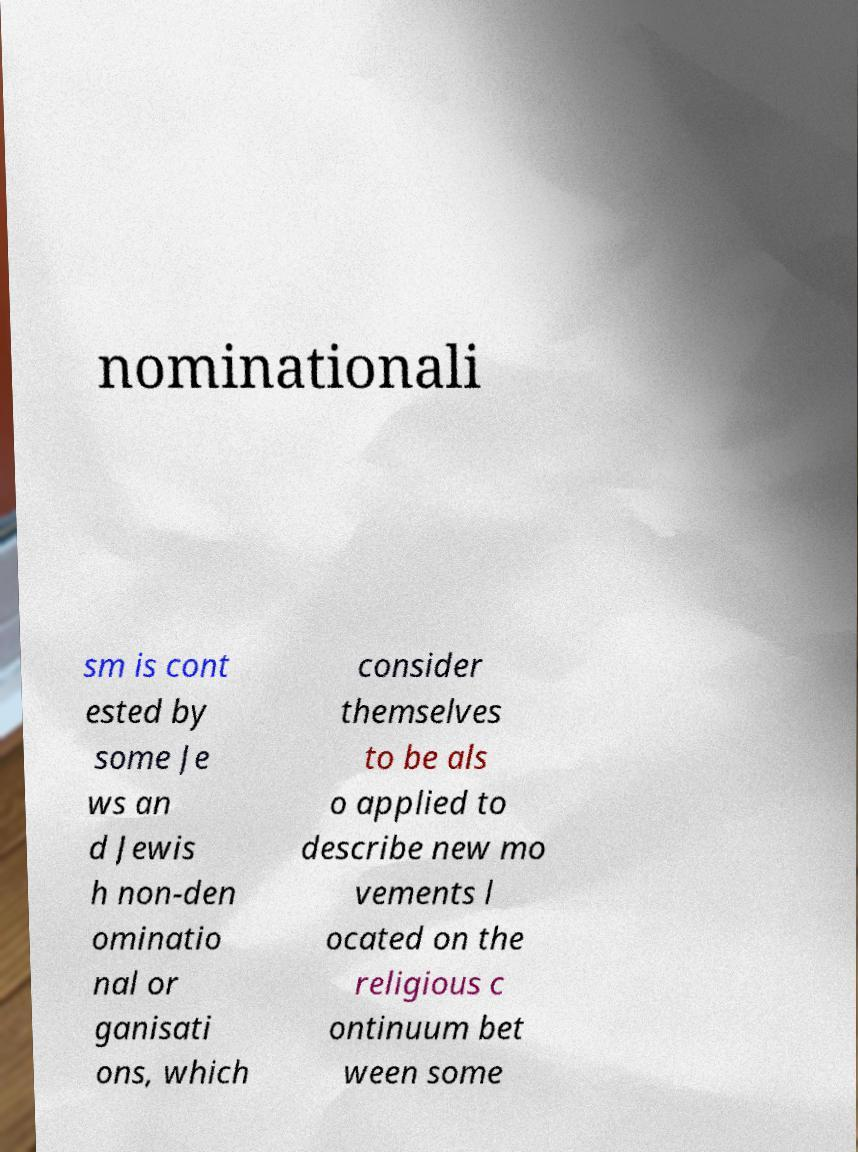Can you accurately transcribe the text from the provided image for me? nominationali sm is cont ested by some Je ws an d Jewis h non-den ominatio nal or ganisati ons, which consider themselves to be als o applied to describe new mo vements l ocated on the religious c ontinuum bet ween some 